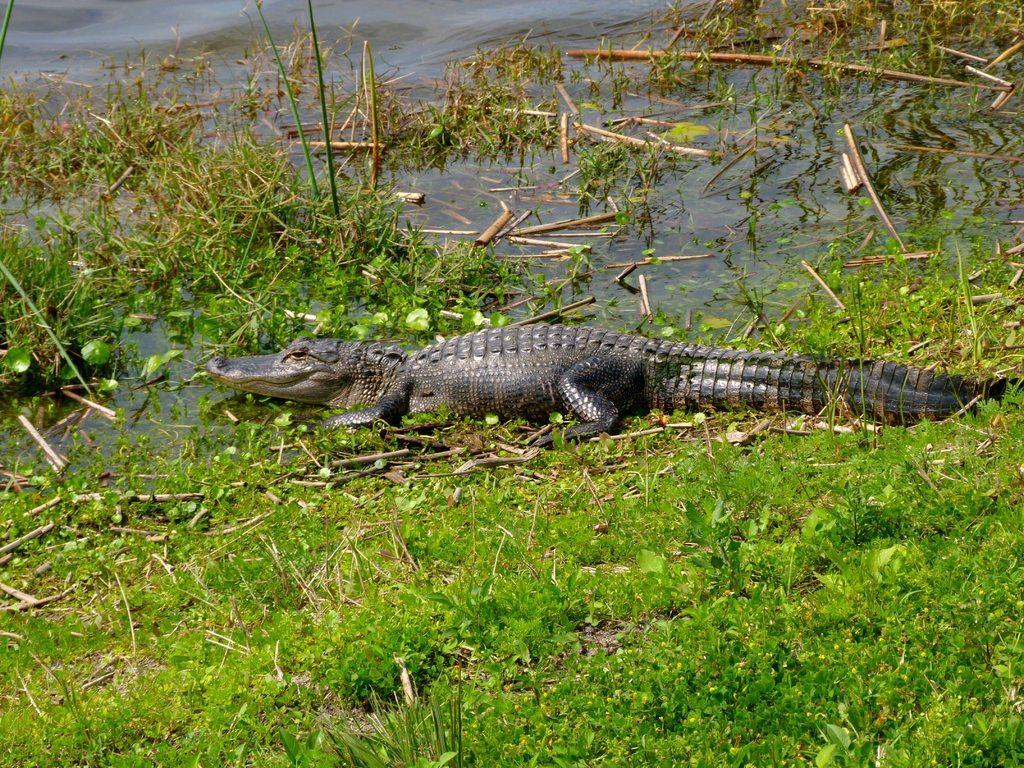Please provide a concise description of this image. In this image we can see the crocodile on the surface of the water and also the grass. 